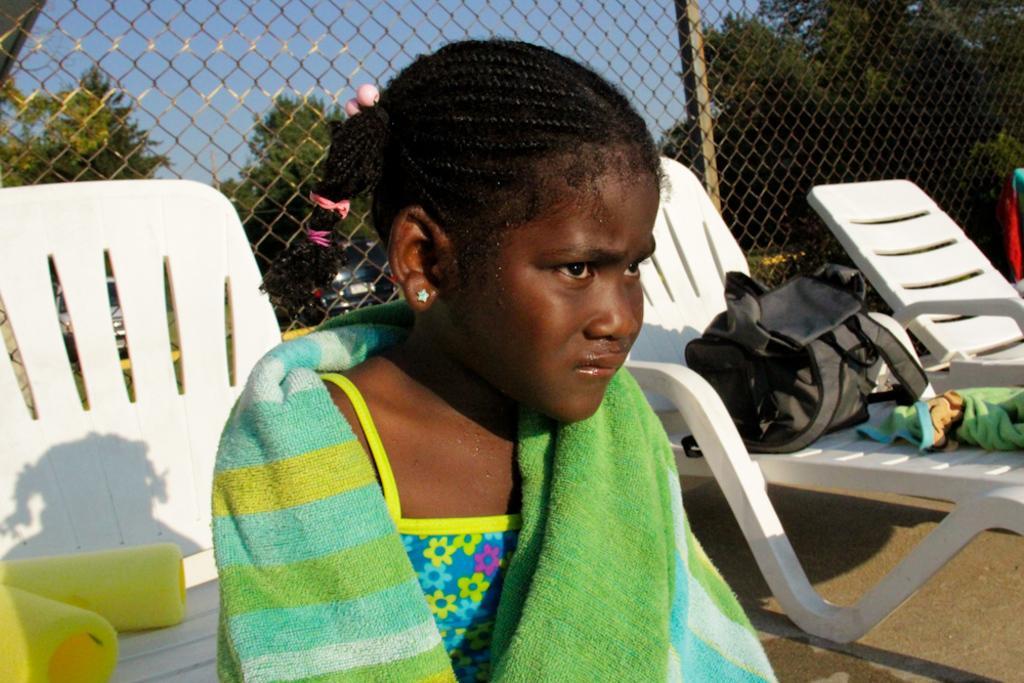How would you summarize this image in a sentence or two? In this picture there is a girl sitting on the chair. 